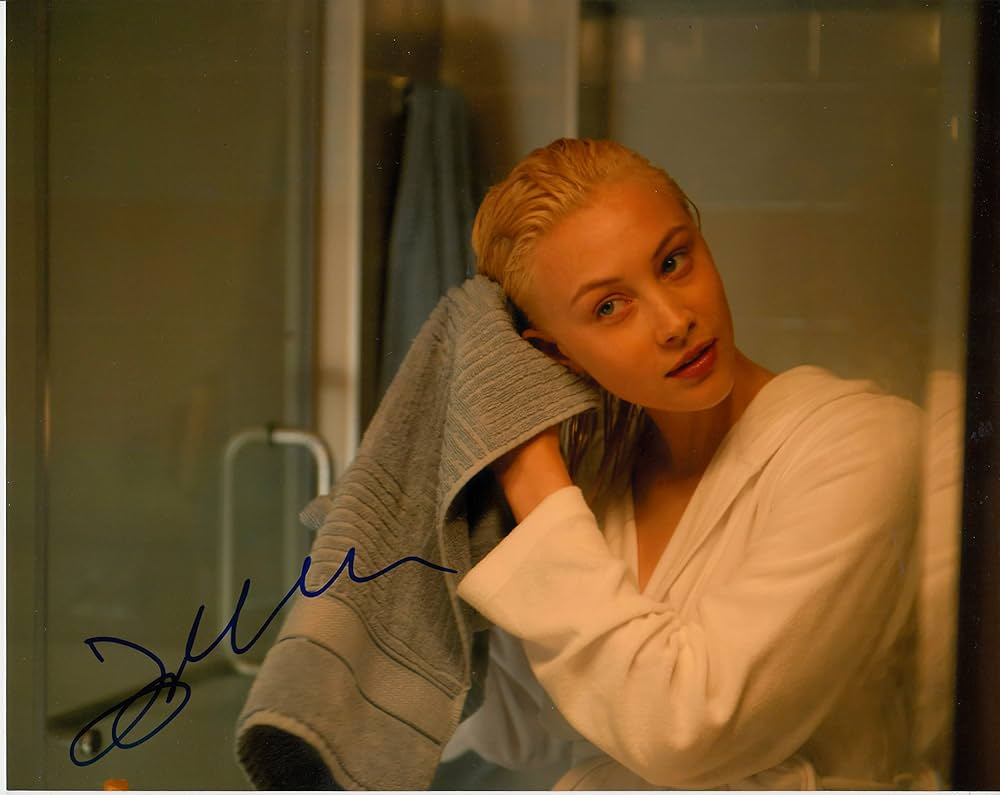Describe how the elements in the background contribute to the overall atmosphere of the image. The elements in the background, notably the muted colors and minimalistic design of the bathroom, contribute significantly to the atmosphere. The absence of vivid colors or distracting patterns ensures that the focus remains on the woman. The simplicity and cleanliness of the background, along with the subtle reflection and translucence of the glass, enhance the peaceful and almost intimate feel of the setting. 